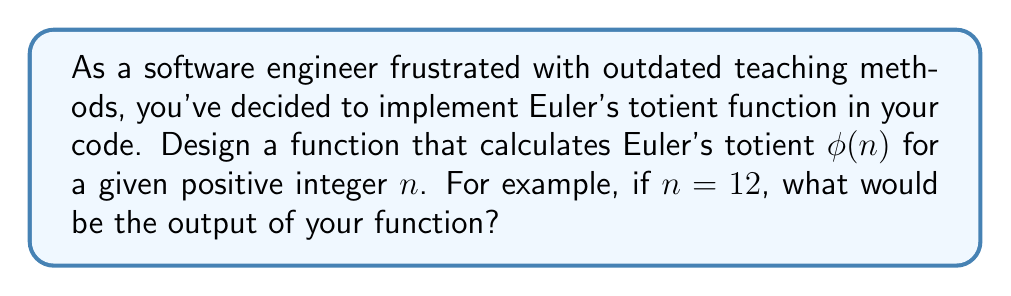Can you solve this math problem? Let's approach this step-by-step:

1) Euler's totient function $\phi(n)$ counts the number of integers from 1 to $n$ that are coprime to $n$.

2) For $n = 12$, we need to count how many numbers from 1 to 12 are coprime to 12.

3) To implement this efficiently, we can use the properties of the totient function:

   a) If $p$ is prime, $\phi(p) = p - 1$
   b) If $p$ is prime and $k > 1$, $\phi(p^k) = p^k - p^{k-1} = p^k(1 - \frac{1}{p})$
   c) If $a$ and $b$ are coprime, $\phi(ab) = \phi(a) \cdot \phi(b)$

4) Factorize 12: $12 = 2^2 \cdot 3$

5) Apply the properties:
   
   $\phi(12) = \phi(2^2) \cdot \phi(3)$
   
   $= (2^2 - 2^1) \cdot (3 - 1)$
   
   $= 2 \cdot 2 = 4$

6) To verify, let's list all numbers from 1 to 12 and check which are coprime to 12:
   1, 5, 7, 11 are coprime to 12. There are indeed 4 such numbers.

7) Therefore, our function should return 4 for input 12.

In code, we could implement this using prime factorization and the multiplicative property of the totient function.
Answer: 4 